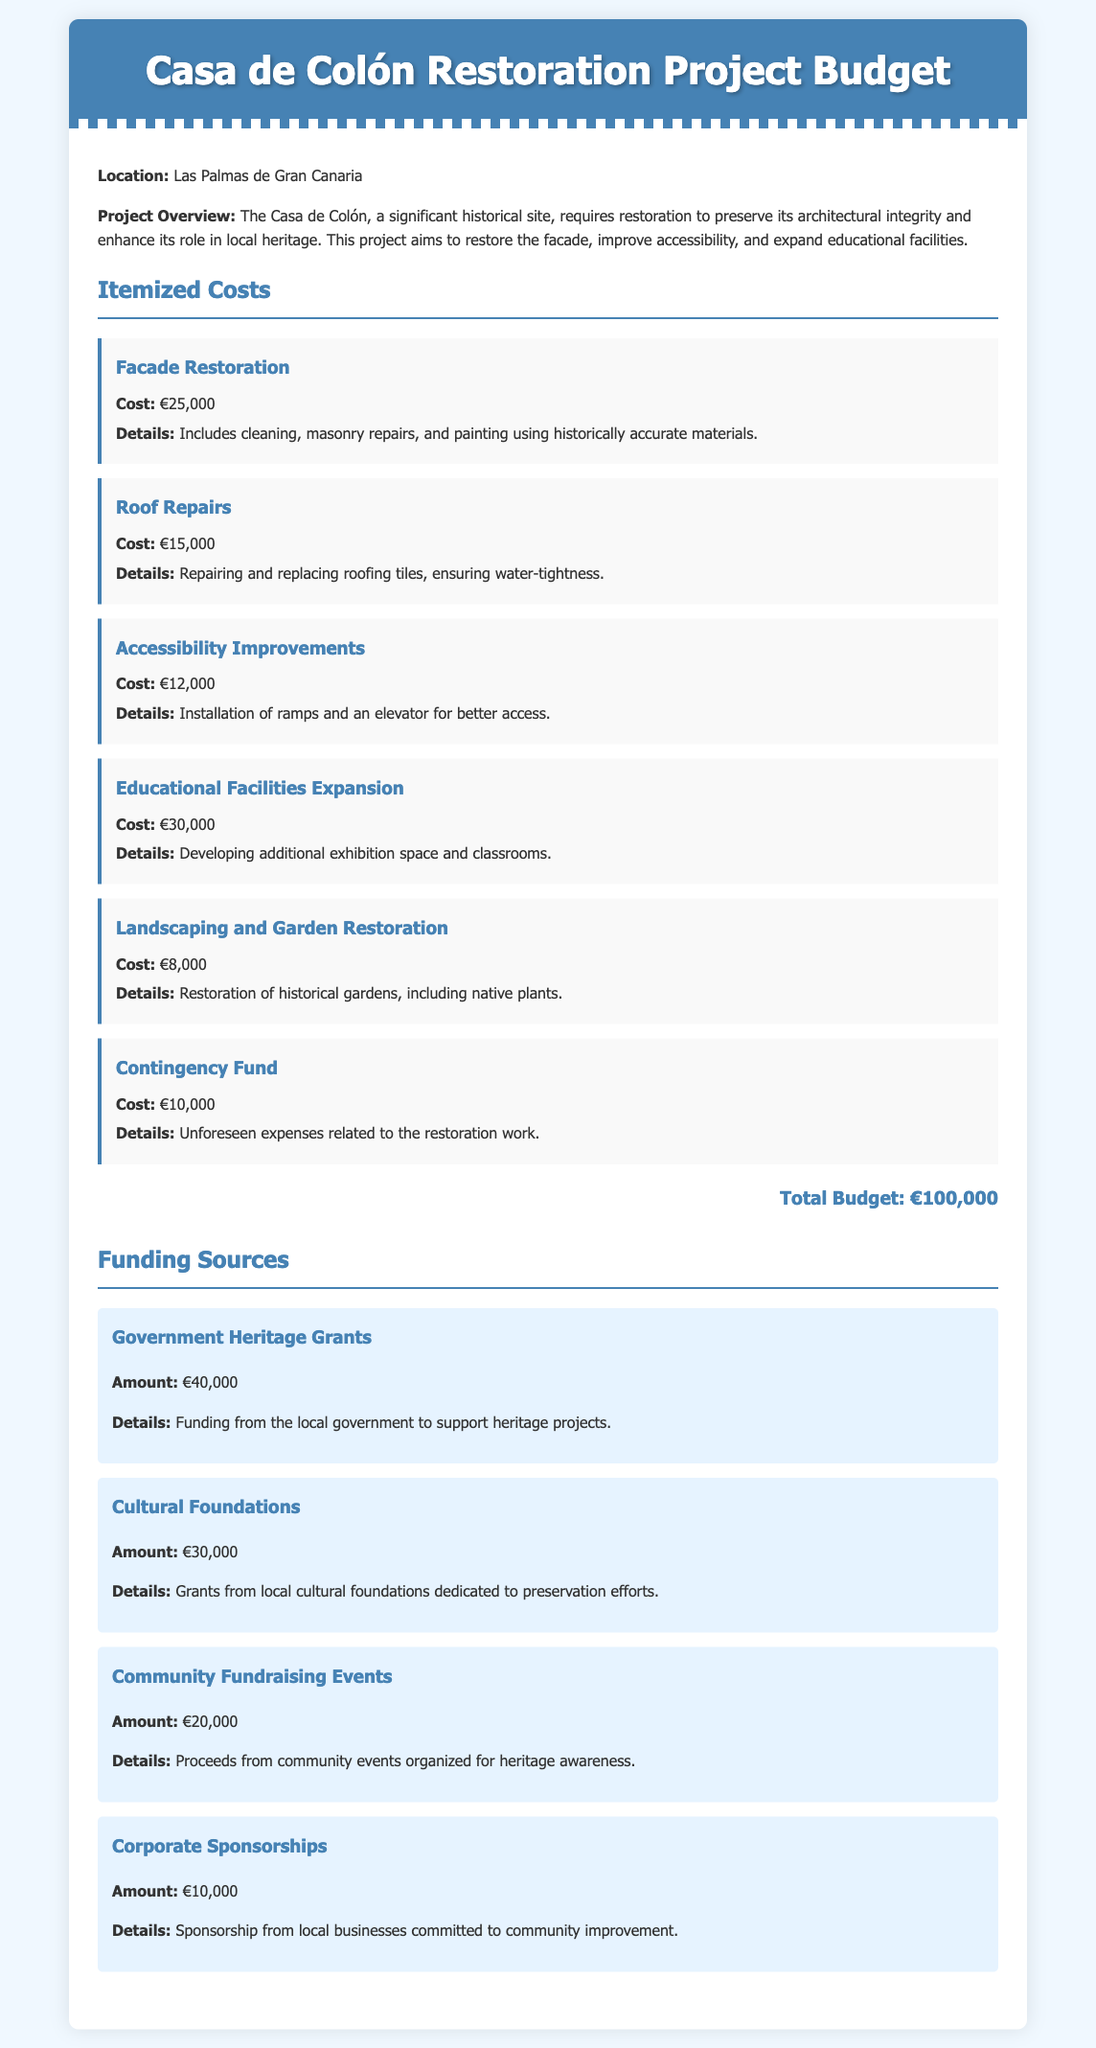What is the total budget for the restoration project? The total budget is listed at the end of the itemized costs section in the document.
Answer: €100,000 How much is allocated for facade restoration? The cost for facade restoration is explicitly stated in the itemized costs section of the document.
Answer: €25,000 What is the cost of accessibility improvements? This cost is mentioned under itemized costs, providing specific information on the project's budget.
Answer: €12,000 What type of funding source contributes €40,000? The funding sources section includes details on distinct funding areas, specifying the amount for each source.
Answer: Government Heritage Grants How many euros are expected from community fundraising events? This amount is clearly stated in the funding sources section of the document.
Answer: €20,000 What is one of the specific details included in the roof repairs cost? The document provides a brief detail about what the roof repairs entail, combining numbers and descriptive text.
Answer: Water-tightness How much does the corporate sponsorship contribute? This is one of the amounts detailed in the funding sources section of the document.
Answer: €10,000 What is included in the contingency fund? The details for the contingency fund are outlined in the itemized costs section, describing its purpose.
Answer: Unforeseen expenses Which section discusses landscaping and garden restoration? The document is divided into sections, with this particular aspect listed in the itemized costs area.
Answer: Itemized Costs 